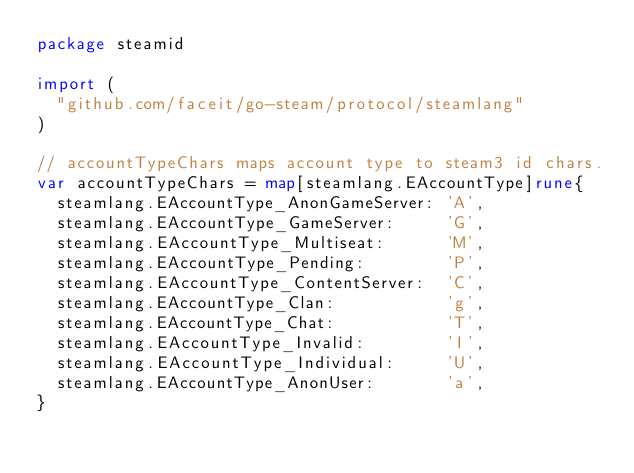<code> <loc_0><loc_0><loc_500><loc_500><_Go_>package steamid

import (
	"github.com/faceit/go-steam/protocol/steamlang"
)

// accountTypeChars maps account type to steam3 id chars.
var accountTypeChars = map[steamlang.EAccountType]rune{
	steamlang.EAccountType_AnonGameServer: 'A',
	steamlang.EAccountType_GameServer:     'G',
	steamlang.EAccountType_Multiseat:      'M',
	steamlang.EAccountType_Pending:        'P',
	steamlang.EAccountType_ContentServer:  'C',
	steamlang.EAccountType_Clan:           'g',
	steamlang.EAccountType_Chat:           'T',
	steamlang.EAccountType_Invalid:        'I',
	steamlang.EAccountType_Individual:     'U',
	steamlang.EAccountType_AnonUser:       'a',
}
</code> 